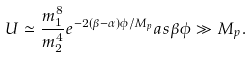Convert formula to latex. <formula><loc_0><loc_0><loc_500><loc_500>U \simeq \frac { m _ { 1 } ^ { 8 } } { m _ { 2 } ^ { 4 } } e ^ { - 2 ( \beta - \alpha ) \phi / M _ { p } } a s \beta \phi \gg M _ { p } .</formula> 